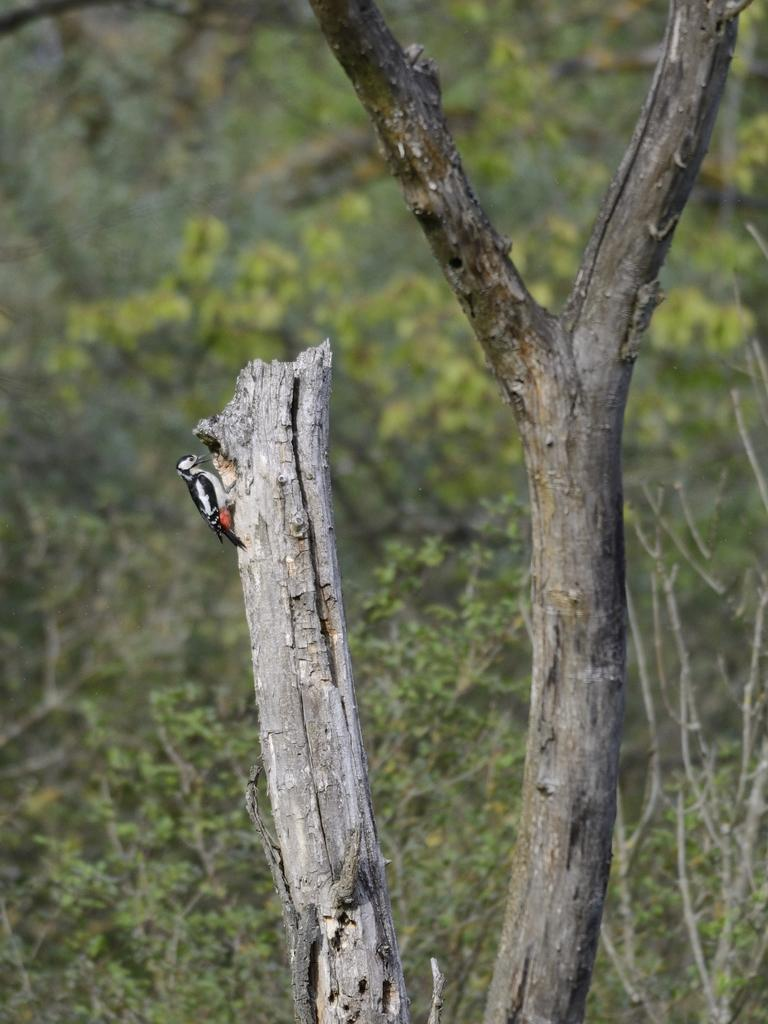What type of bird is in the image? There is a woodpecker in the image. Where is the woodpecker located? The woodpecker is on a tree branch. How would you describe the background of the image? The background of the image is slightly blurred. What can be seen in the background of the image? There are plants and trees in the background of the image. What type of fruit is the woodpecker eating in the image? There is no fruit present in the image, and the woodpecker is not shown eating anything. 